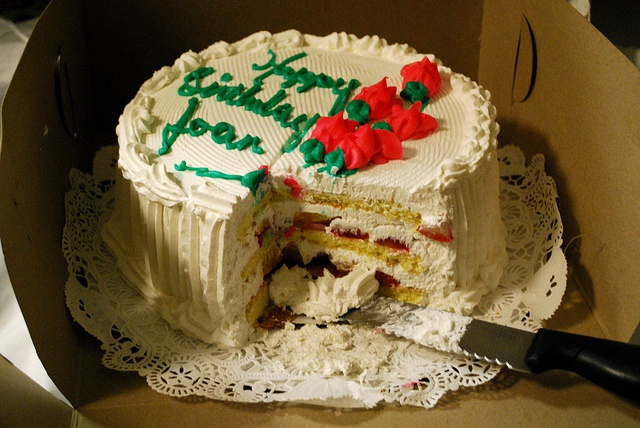Describe the objects in this image and their specific colors. I can see cake in black, tan, and olive tones and knife in black, tan, olive, and beige tones in this image. 